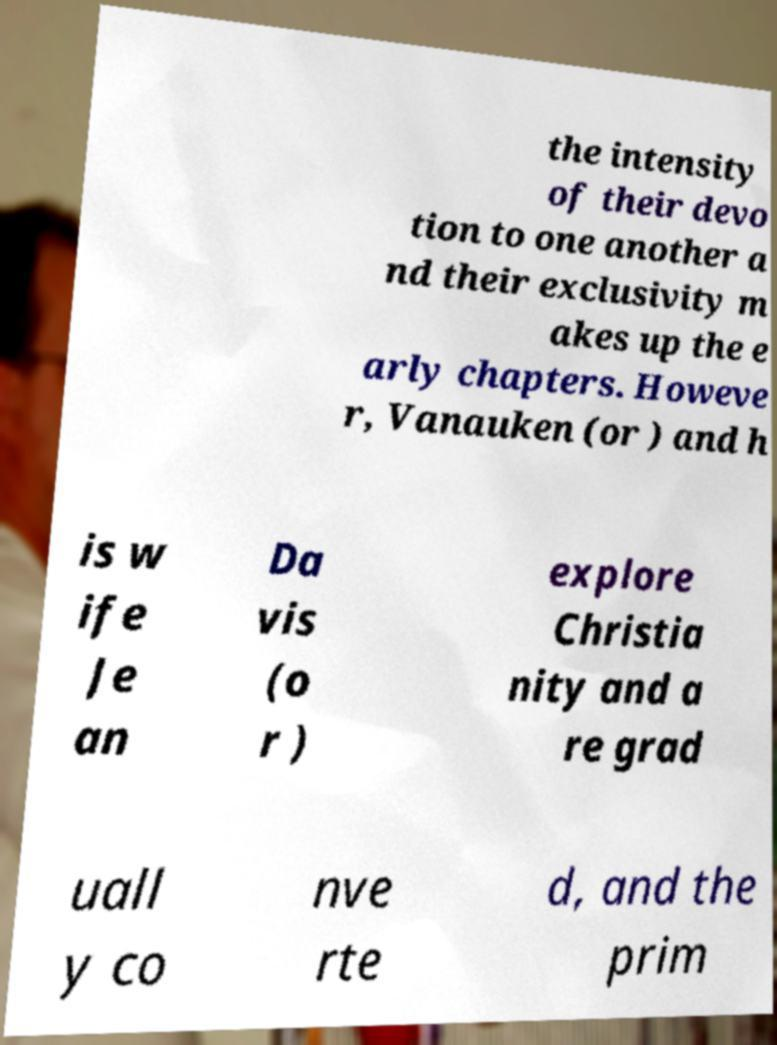I need the written content from this picture converted into text. Can you do that? the intensity of their devo tion to one another a nd their exclusivity m akes up the e arly chapters. Howeve r, Vanauken (or ) and h is w ife Je an Da vis (o r ) explore Christia nity and a re grad uall y co nve rte d, and the prim 